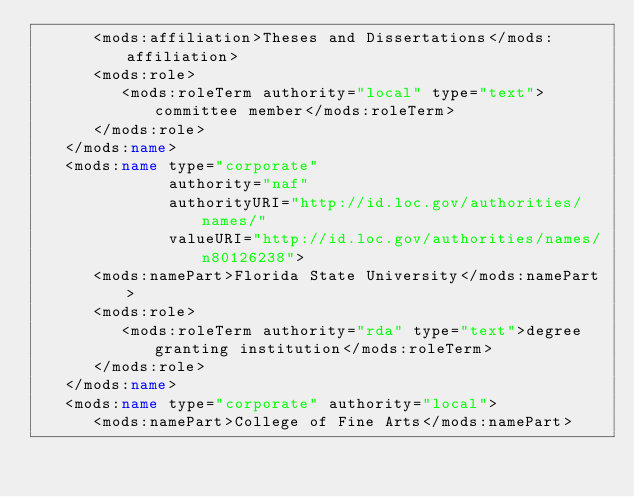<code> <loc_0><loc_0><loc_500><loc_500><_XML_>      <mods:affiliation>Theses and Dissertations</mods:affiliation>
      <mods:role>
         <mods:roleTerm authority="local" type="text">committee member</mods:roleTerm>
      </mods:role>
   </mods:name>
   <mods:name type="corporate"
              authority="naf"
              authorityURI="http://id.loc.gov/authorities/names/"
              valueURI="http://id.loc.gov/authorities/names/n80126238">
      <mods:namePart>Florida State University</mods:namePart>
      <mods:role>
         <mods:roleTerm authority="rda" type="text">degree granting institution</mods:roleTerm>
      </mods:role>
   </mods:name>
   <mods:name type="corporate" authority="local">
      <mods:namePart>College of Fine Arts</mods:namePart></code> 